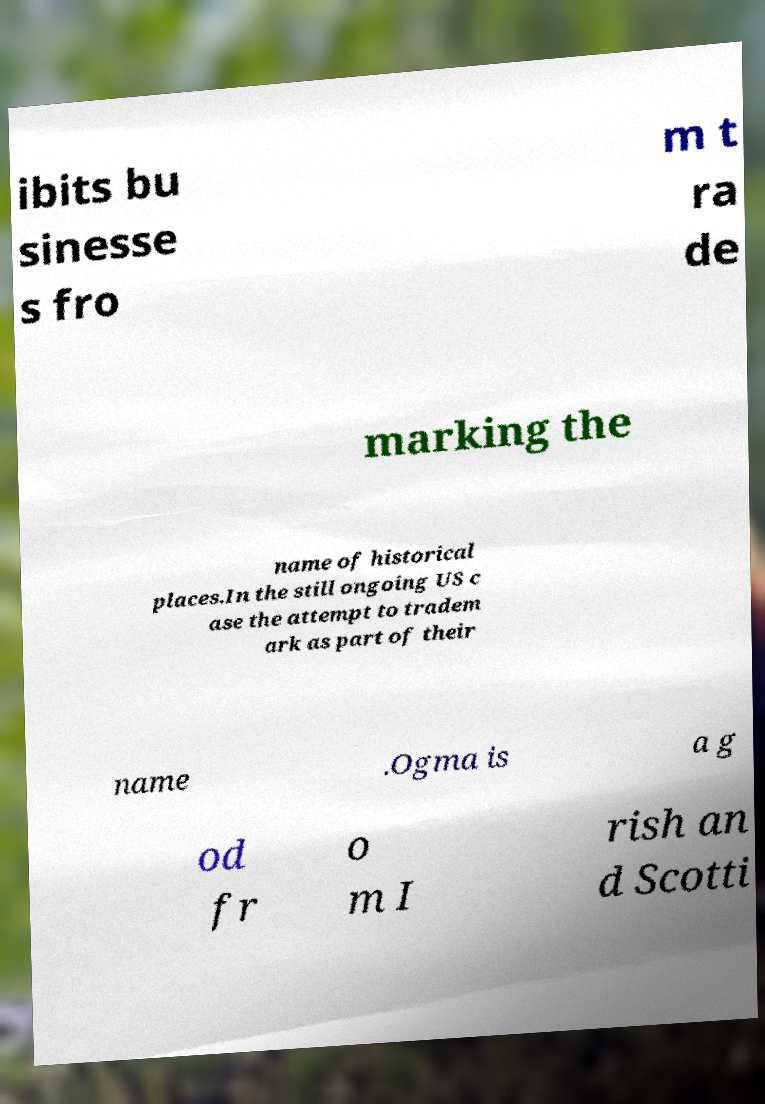I need the written content from this picture converted into text. Can you do that? ibits bu sinesse s fro m t ra de marking the name of historical places.In the still ongoing US c ase the attempt to tradem ark as part of their name .Ogma is a g od fr o m I rish an d Scotti 